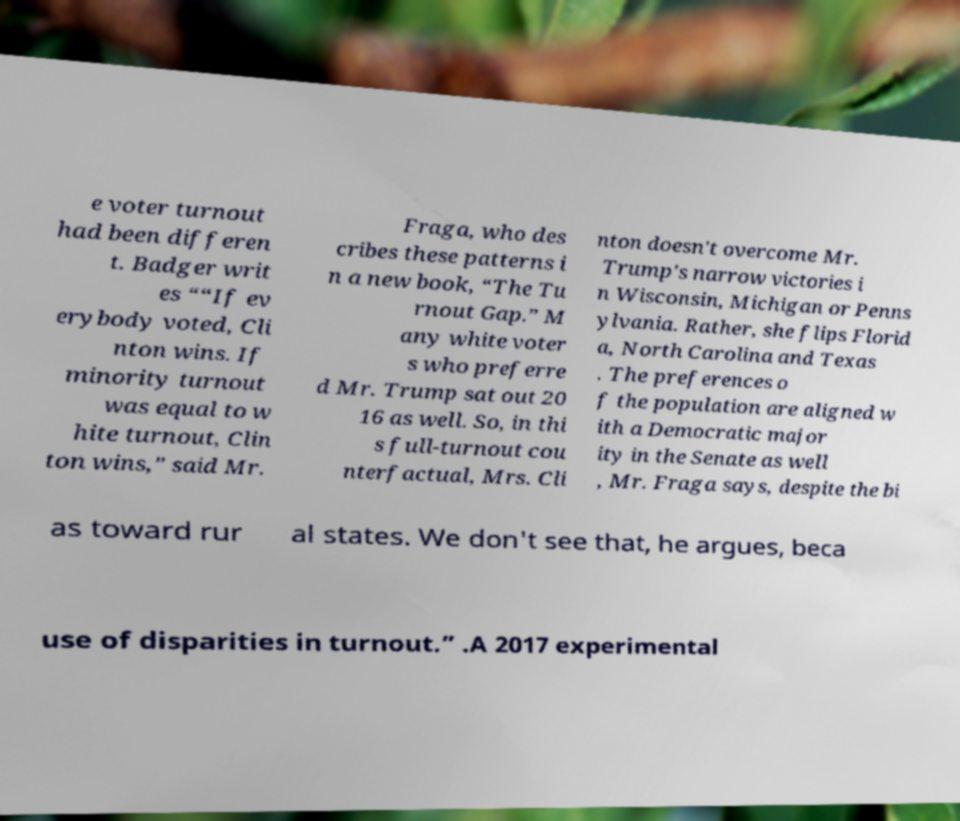Could you extract and type out the text from this image? e voter turnout had been differen t. Badger writ es ““If ev erybody voted, Cli nton wins. If minority turnout was equal to w hite turnout, Clin ton wins,” said Mr. Fraga, who des cribes these patterns i n a new book, “The Tu rnout Gap.” M any white voter s who preferre d Mr. Trump sat out 20 16 as well. So, in thi s full-turnout cou nterfactual, Mrs. Cli nton doesn't overcome Mr. Trump's narrow victories i n Wisconsin, Michigan or Penns ylvania. Rather, she flips Florid a, North Carolina and Texas . The preferences o f the population are aligned w ith a Democratic major ity in the Senate as well , Mr. Fraga says, despite the bi as toward rur al states. We don't see that, he argues, beca use of disparities in turnout.” .A 2017 experimental 